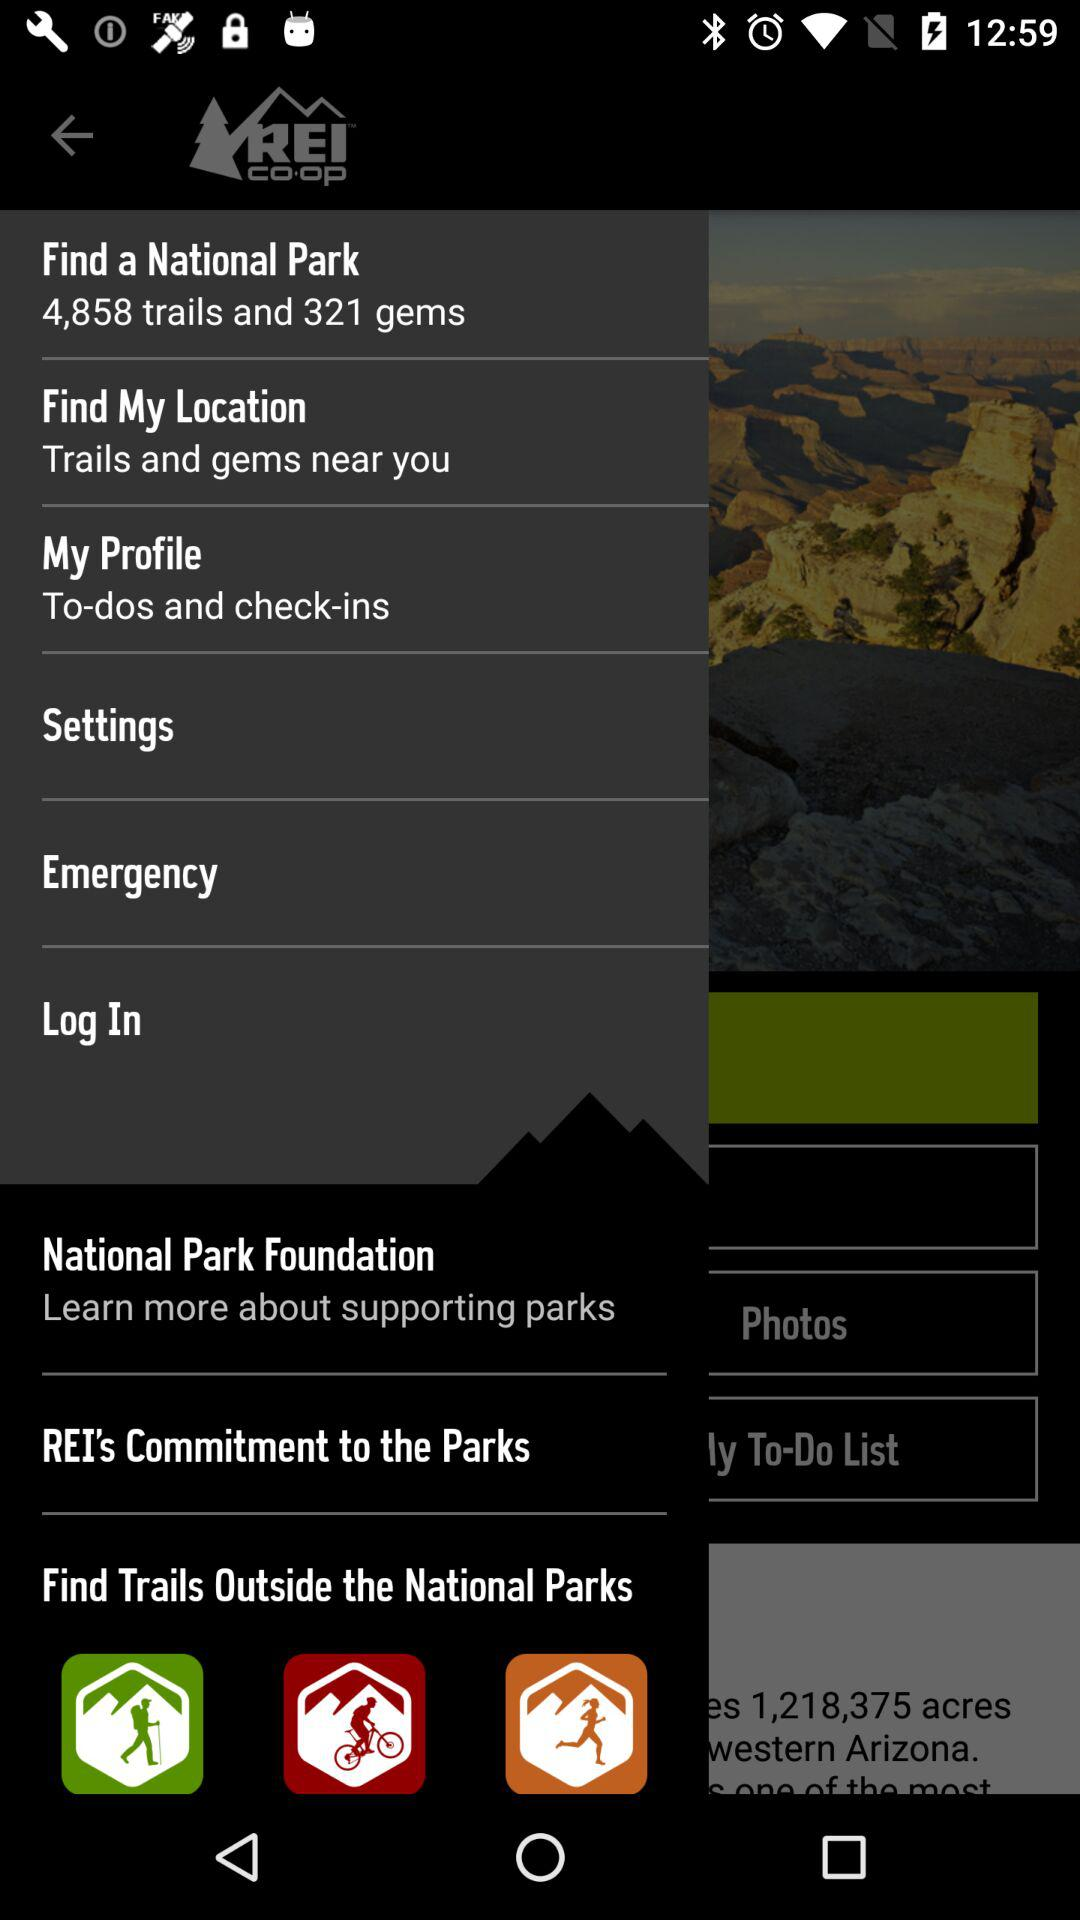How many more trails are there than gems?
Answer the question using a single word or phrase. 4537 